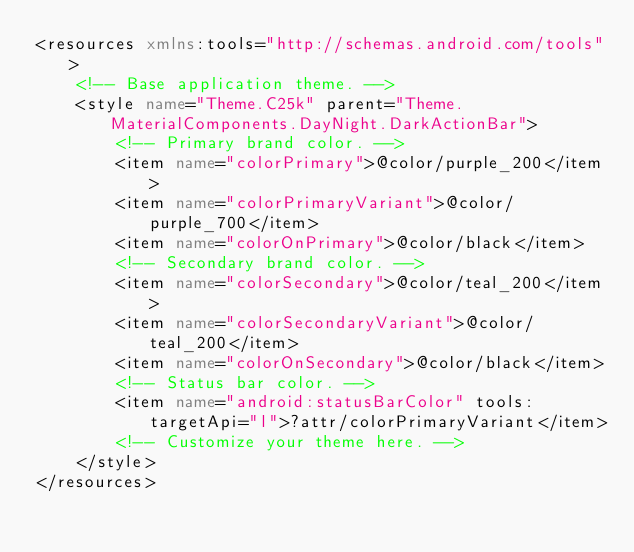Convert code to text. <code><loc_0><loc_0><loc_500><loc_500><_XML_><resources xmlns:tools="http://schemas.android.com/tools">
    <!-- Base application theme. -->
    <style name="Theme.C25k" parent="Theme.MaterialComponents.DayNight.DarkActionBar">
        <!-- Primary brand color. -->
        <item name="colorPrimary">@color/purple_200</item>
        <item name="colorPrimaryVariant">@color/purple_700</item>
        <item name="colorOnPrimary">@color/black</item>
        <!-- Secondary brand color. -->
        <item name="colorSecondary">@color/teal_200</item>
        <item name="colorSecondaryVariant">@color/teal_200</item>
        <item name="colorOnSecondary">@color/black</item>
        <!-- Status bar color. -->
        <item name="android:statusBarColor" tools:targetApi="l">?attr/colorPrimaryVariant</item>
        <!-- Customize your theme here. -->
    </style>
</resources></code> 